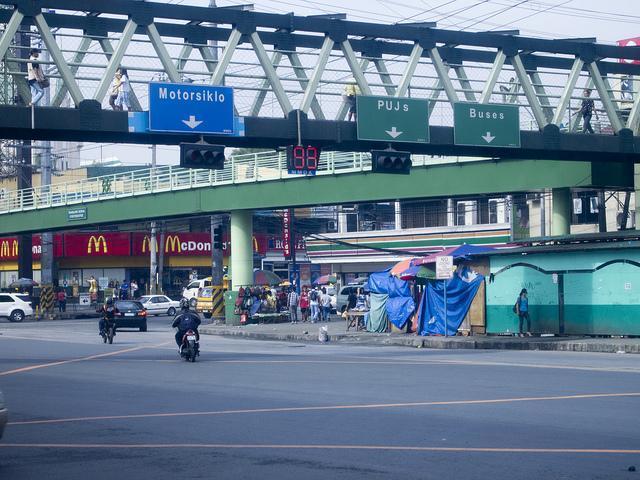How many giraffes are in this scene?
Give a very brief answer. 0. 